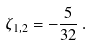<formula> <loc_0><loc_0><loc_500><loc_500>\zeta _ { 1 , 2 } = - \frac { 5 } { 3 2 } \, .</formula> 